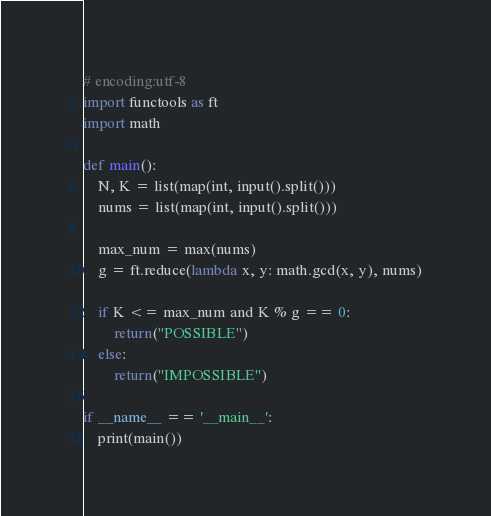Convert code to text. <code><loc_0><loc_0><loc_500><loc_500><_Python_># encoding:utf-8
import functools as ft
import math

def main():
	N, K = list(map(int, input().split()))
	nums = list(map(int, input().split()))

	max_num = max(nums)
	g = ft.reduce(lambda x, y: math.gcd(x, y), nums)

	if K <= max_num and K % g == 0:
		return("POSSIBLE")
	else:
		return("IMPOSSIBLE")

if __name__ == '__main__':
	print(main())</code> 